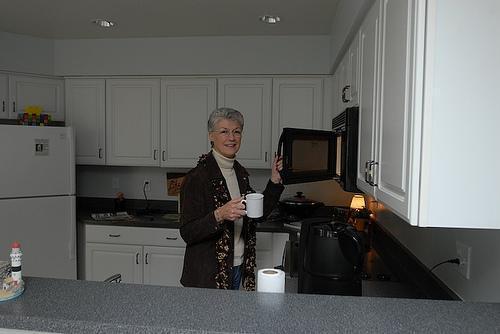How many people are in this picture?
Give a very brief answer. 1. How many lights are visible?
Give a very brief answer. 3. How many colors of microwaves does the woman have?
Give a very brief answer. 1. How many people are above the sink?
Give a very brief answer. 1. 